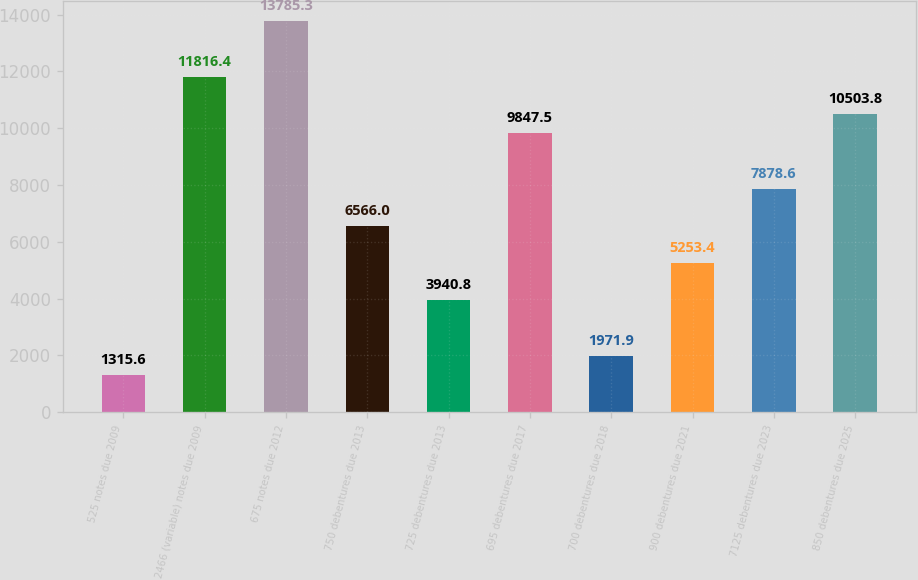<chart> <loc_0><loc_0><loc_500><loc_500><bar_chart><fcel>525 notes due 2009<fcel>2466 (variable) notes due 2009<fcel>675 notes due 2012<fcel>750 debentures due 2013<fcel>725 debentures due 2013<fcel>695 debentures due 2017<fcel>700 debentures due 2018<fcel>900 debentures due 2021<fcel>7125 debentures due 2023<fcel>850 debentures due 2025<nl><fcel>1315.6<fcel>11816.4<fcel>13785.3<fcel>6566<fcel>3940.8<fcel>9847.5<fcel>1971.9<fcel>5253.4<fcel>7878.6<fcel>10503.8<nl></chart> 